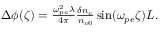Convert formula to latex. <formula><loc_0><loc_0><loc_500><loc_500>\begin{array} { r } { \Delta \phi ( \zeta ) = \frac { \omega _ { p e } ^ { 2 } \lambda } { 4 \pi } \frac { \delta n _ { e } } { n _ { e 0 } } \sin ( \omega _ { p e } \zeta ) L . } \end{array}</formula> 